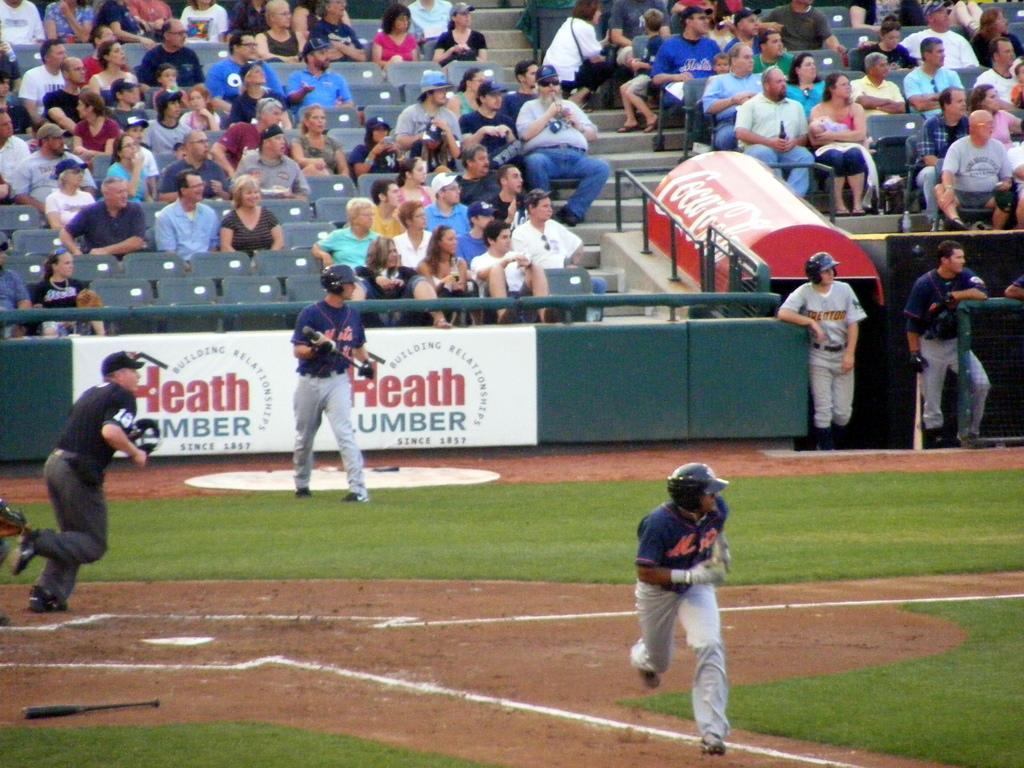What is the red word on the wall behind the player?
Your answer should be very brief. Heath. What company is the white and red advertisement banner for?
Your answer should be compact. Heath lumber. 